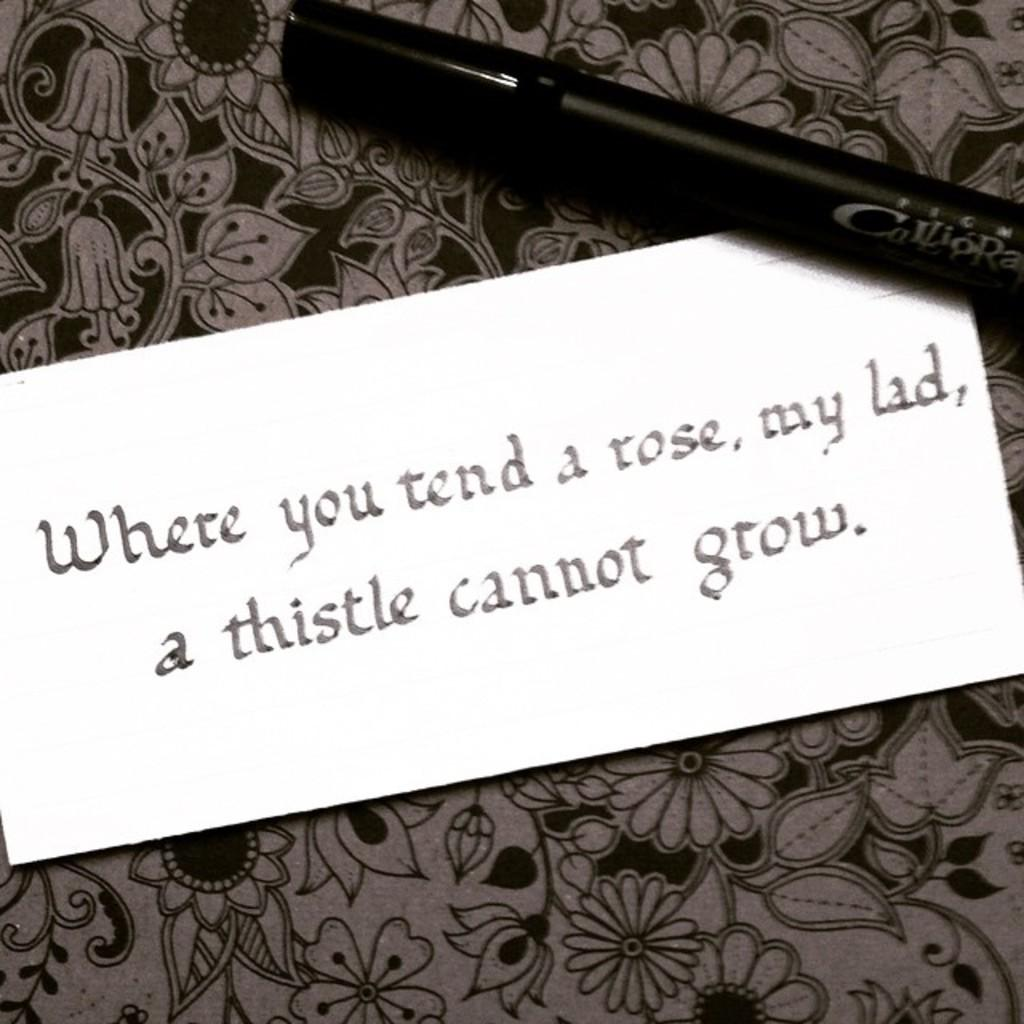What is the main object in the image with text on it? There is a card with text in the image. What color is the marker that is visible in the image? The marker in the image is black. What type of noise can be heard coming from the card in the image? There is no noise coming from the card in the image, as it is a stationary object with text on it. 